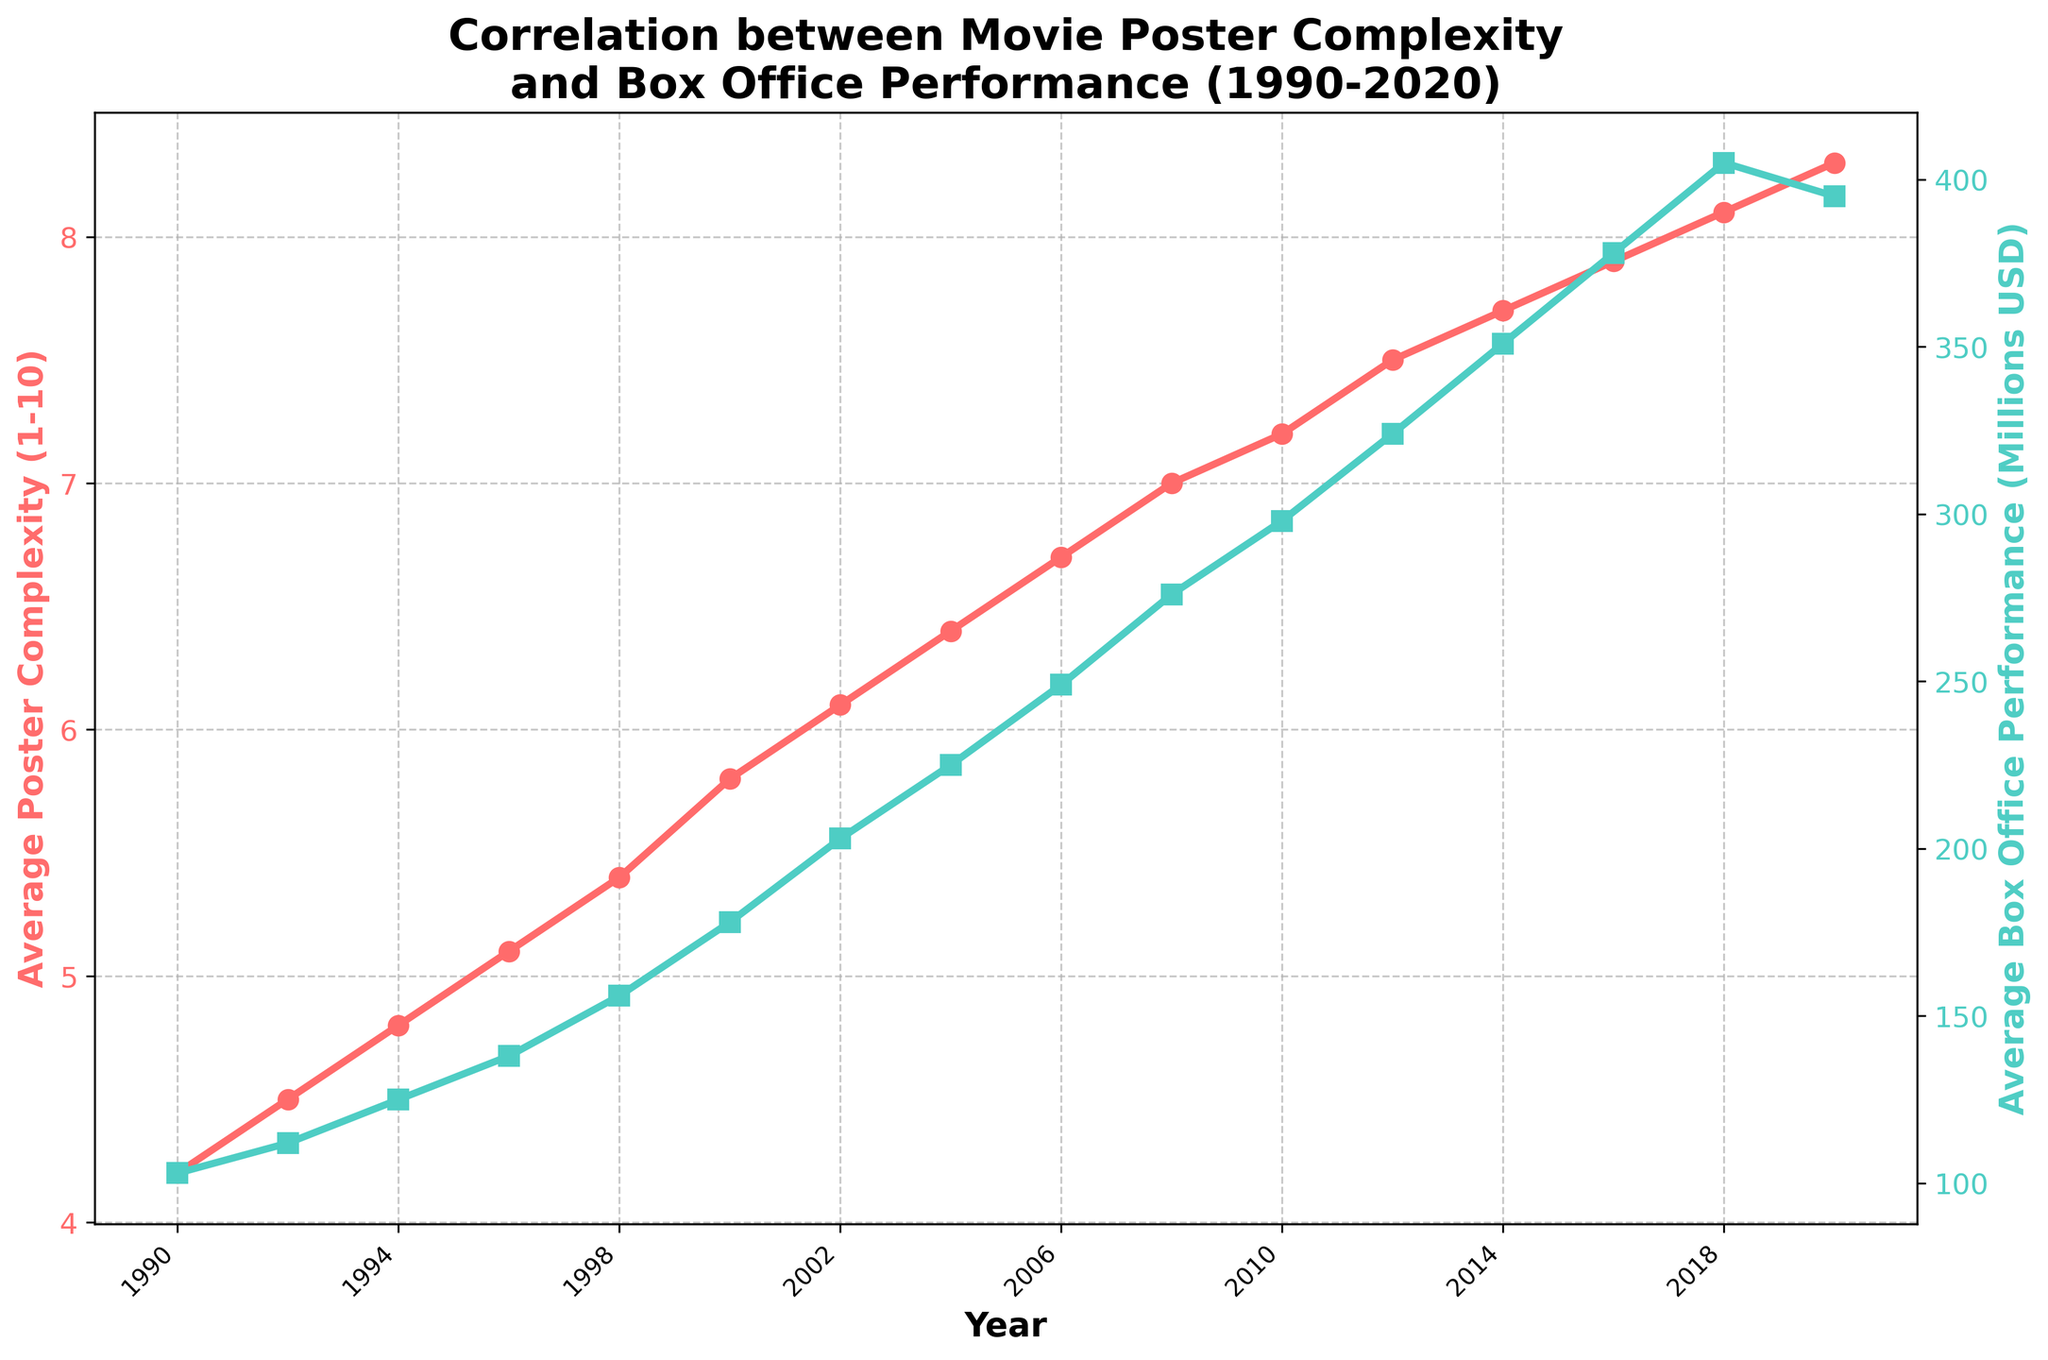What is the trend in Average Poster Complexity from 1990 to 2020? The Average Poster Complexity shows a consistent increasing trend from 4.2 in 1990 to 8.3 in 2020.
Answer: Increasing What is the highest Average Box Office Performance recorded in the given data? In 2018, the Average Box Office Performance peaks at 405 million USD, as represented by the highest point in the green line.
Answer: 405 million USD How does the Average Poster Complexity in 2000 compare to that in 2010? In 2000, the Average Poster Complexity is 5.8, while in 2010 it is 7.2. Therefore, there is an increase of 1.4 points over this period.
Answer: 1.4 points increase What is the correlation between the increase in Average Poster Complexity and Average Box Office Performance from 2004 to 2008? Between 2004 and 2008, the Average Poster Complexity increases from 6.4 to 7.0, and the Average Box Office Performance increases from 225 million USD to 276 million USD, indicating a positive correlation.
Answer: Positive correlation Which year shows a decline in Average Box Office Performance despite an increase in Average Poster Complexity? In 2020, the Average Poster Complexity increases to 8.3, but the Average Box Office Performance decreases to 395 million USD from 405 million USD in 2018.
Answer: 2020 How much did the Average Box Office Performance increase from 1990 to 2010? The Average Box Office Performance in 1990 is 103 million USD, and it increases to 298 million USD in 2010. The increase is 298 - 103 = 195 million USD.
Answer: 195 million USD Between which consecutive years is the increase in Average Poster Complexity the greatest? The greatest increase in Average Poster Complexity occurs between 1998 (5.4) and 2000 (5.8), which is an increase of 0.4 points.
Answer: Between 1998 and 2000 Describe the color and trends of the two lines in the chart. The red line represents the Average Poster Complexity with a steadily increasing trend, while the green line represents the Average Box Office Performance, also increasing but with a slight dip in 2020.
Answer: Red and green lines; increasing trends If the Average Box Office Performance trend continues, what are the implications for the complexity of movie posters? Since the data indicates a positive correlation between poster complexity and box office performance, a continued increase in box office performance would likely be associated with increasing poster complexity.
Answer: Continued increase in complexity Compare the growth rates of Average Poster Complexity and Average Box Office Performance from 1990 to 2020. The Average Poster Complexity grows from 4.2 to 8.3 (an increase of 4.1 points), whereas the Average Box Office Performance grows from 103 million USD to 395 million USD (an increase of 292 million USD). Poster complexity roughly doubles, while box office performance nearly quadruples.
Answer: Poster complexity doubles, box office nearly quadruples 